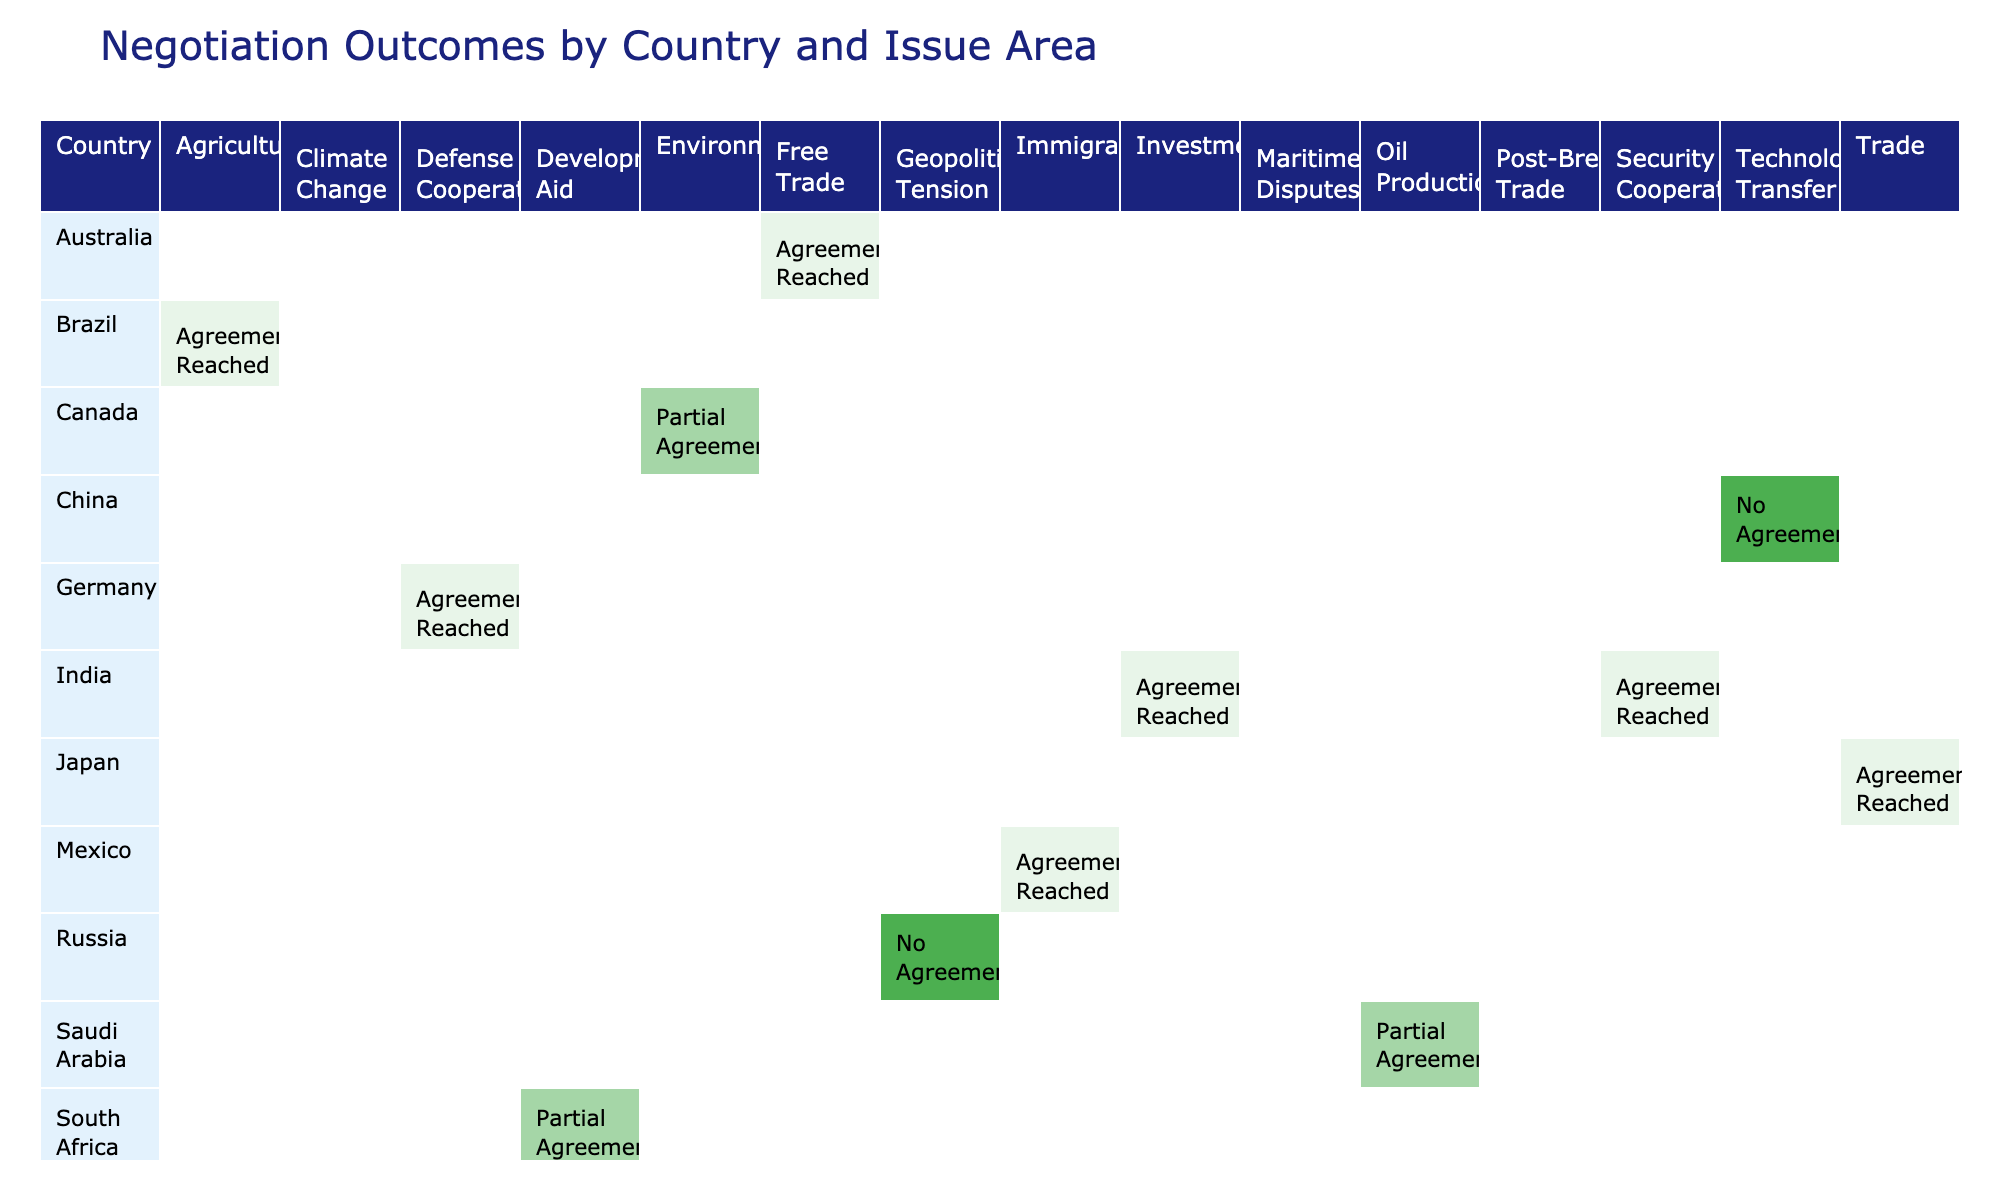What was the outcome of the negotiation between the United States and China regarding trade? The table shows that the outcome for the negotiation between the United States and China related to trade was an "Agreement Reached."
Answer: Agreement Reached How many issue areas resulted in a partial agreement between countries? Reviewing the table, the issue areas that resulted in a partial agreement are Climate Change (United States, India), Environment (Canada, United States), Development Aid (South Africa, Nigeria), and Oil Production (Saudi Arabia, Iran). Therefore, there are 4 issue areas with partial agreements.
Answer: 4 Did India reach an agreement on investment with Japan? According to the table, India and Japan did reach an agreement on investment, marked as "Agreement Reached".
Answer: Yes What is the total number of agreements reached in the table? The agreements reached are regarding Trade (United States, China), Security Cooperation (India, European Union), Agriculture (Brazil, Argentina), Trade (Japan, South Korea), Free Trade (Australia, New Zealand), Immigration (Mexico, United States), and Investment (India, Japan). Thus, there are 7 agreements.
Answer: 7 Which country pair has the least favorable outcome in terms of agreement? Observing the table, the country pair with the least favorable outcome is Turkey and Greece regarding Maritime Disputes, which resulted in "No Agreement".
Answer: Turkey and Greece How does the outcome of negotiations on oil production compare to those on technology transfer? The table shows that the outcome for oil production between Saudi Arabia and Iran is a partial agreement, while the outcome for technology transfer between China and the European Union is no agreement. Therefore, oil production had a more favorable outcome than technology transfer.
Answer: More favorable What issue area has the highest number of agreements reached? By analyzing the table, we can see that Trade has multiple entries; however, upon inspection, there is only one entry for trade between each country pair (e.g., United States and China, Japan and South Korea). The issue area with the highest individual entries is actually Trade, with two agreements reached.
Answer: Trade Are there any countries that did not reach an agreement on any issue? Looking at the table, Russia and Ukraine concerning geopolitical tension and Turkey and Greece regarding maritime disputes both have outcomes listed as "No Agreement." Thus, there are countries that did not reach any agreements.
Answer: Yes 